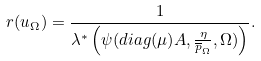Convert formula to latex. <formula><loc_0><loc_0><loc_500><loc_500>r ( u _ { \Omega } ) = \frac { 1 } { \lambda ^ { * } \left ( \psi ( d i a g { ( \mu ) } A , \frac { \eta } { \overline { p } _ { \Omega } } , \Omega ) \right ) } .</formula> 